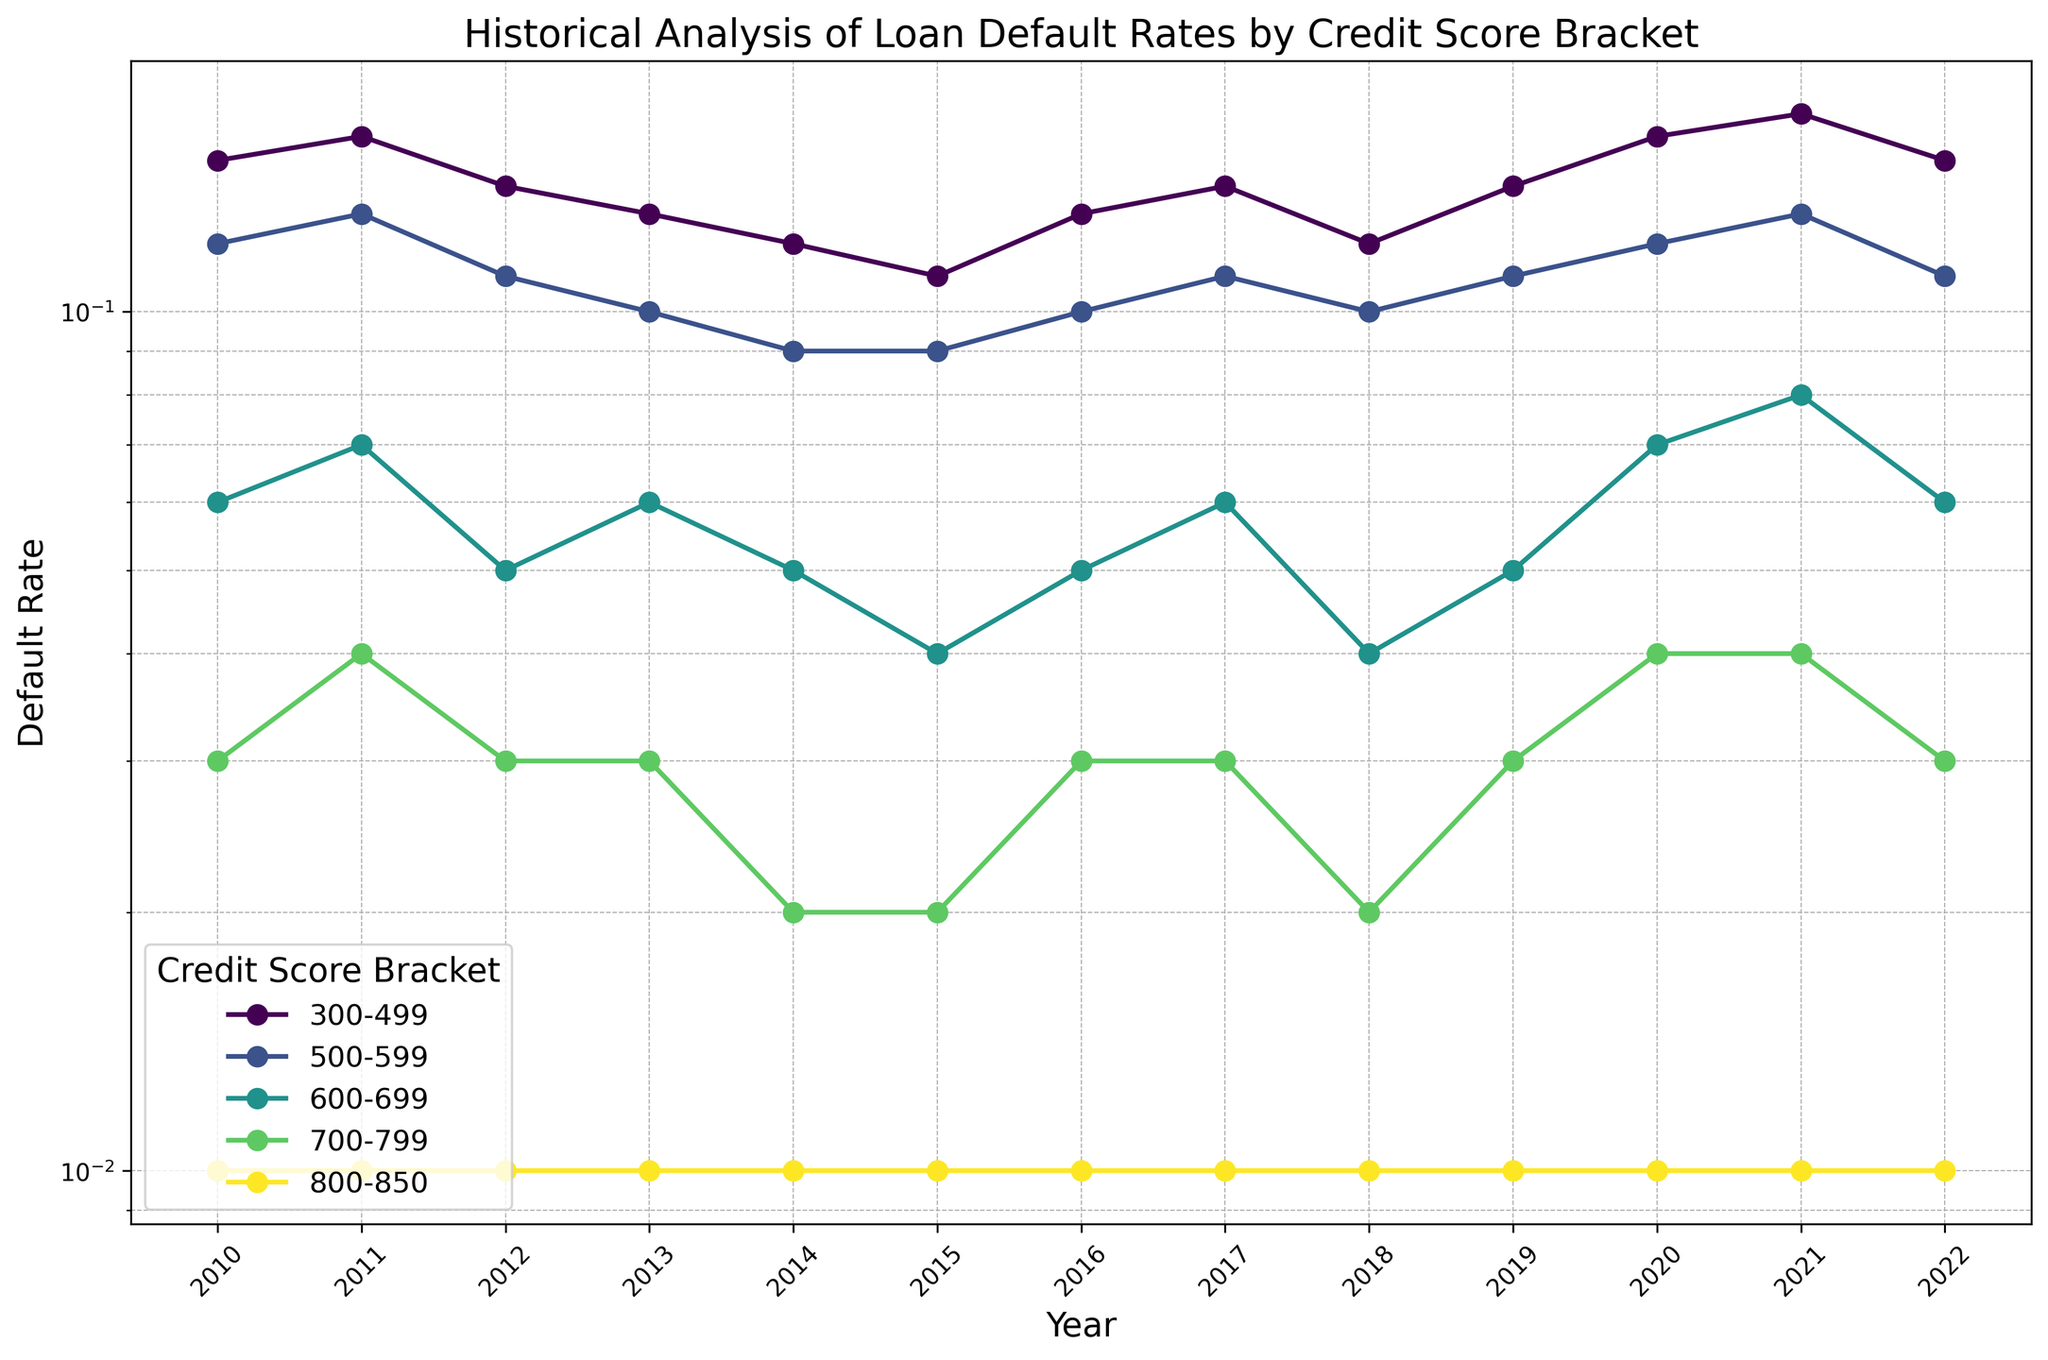How has the default rate for the 300-499 credit score bracket changed from 2010 to 2022? The default rate for the 300-499 credit score bracket in 2010 was 0.15. In 2022, it was 0.15 as well. By comparing these two years, we can see there was no change in the default rate for this bracket over this period.
Answer: 0.15 in 2010 and 0.15 in 2022, no change Which credit score bracket showed the smallest fluctuation in default rate over the years? To find the bracket with the smallest fluctuation, observe the lines on the plot that remain the flattest over the years. The 800-850 bracket consistently stays at 0.01 without any fluctuation.
Answer: 800-850 What year had the highest default rate across all credit score brackets? By examining the plot, we can identify that the year with the highest default rate in the 300-499 bracket is 2021, with a value of 0.17. No other bracket or year surpasses this value.
Answer: 2021 Which years experienced the same default rate for the 600-699 credit score bracket? By following the trend line for the 600-699 credit score bracket, the years 2010 and 2017 both show a default rate of 0.06.
Answer: 2010, 2017 What is the average default rate for the 700-799 credit score bracket from 2010 to 2022? Compute the average by summing the default rates for the 700-799 bracket from 2010 to 2022 and dividing by the number of years (0.03+0.04+0.03+0.03+0.02+0.02+0.03+0.03+0.02+0.03+0.04+0.04+0.03 = 0.39, 0.39/13). The average default rate is approximately 0.03.
Answer: 0.03 Between the years 2015 and 2019, which credit score bracket saw an increase in default rate? Examine the trend lines between 2015 and 2019. The 300-499 bracket shows an increase from 0.11 in 2015 to 0.14 in 2019.
Answer: 300-499 Compare the default rates for the 500-599 credit score bracket in 2015 and 2021. What is the difference? The default rate for the 500-599 credit score bracket in 2015 was 0.09. In 2021, it was 0.13. The difference is 0.13 - 0.09.
Answer: 0.04 Did any credit score bracket experience a decreasing trend in default rates from 2010 to 2022? Analyze the downward trends for any bracket; 500-599 shows a peak of 0.13 in 2011, gradually decreasing to 0.11 in 2022.
Answer: Yes, 500-599 In which year did the 700-799 credit score bracket have a default rate equal to that of the 600-699 credit score bracket? Identify overlaps in default rates on the graph. Both the 700-799 and 600-699 credit score brackets had a default rate of 0.06 in 2010 and 2017.
Answer: 2010 and 2017 Which credit score bracket had a stable default rate of 0.01 throughout the period from 2010 to 2022? Observe the plot for horizontal lines at the 0.01 level. The 800-850 score bracket maintained a stable default rate of 0.01.
Answer: 800-850 